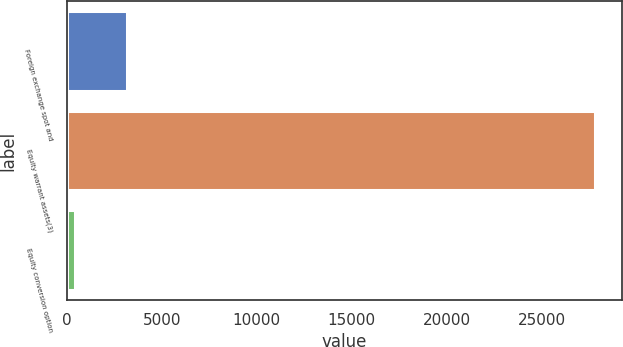Convert chart to OTSL. <chart><loc_0><loc_0><loc_500><loc_500><bar_chart><fcel>Foreign exchange spot and<fcel>Equity warrant assets(3)<fcel>Equity conversion option<nl><fcel>3186.1<fcel>27802<fcel>451<nl></chart> 